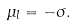Convert formula to latex. <formula><loc_0><loc_0><loc_500><loc_500>\mu _ { l } = - \sigma .</formula> 